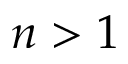<formula> <loc_0><loc_0><loc_500><loc_500>n > 1</formula> 